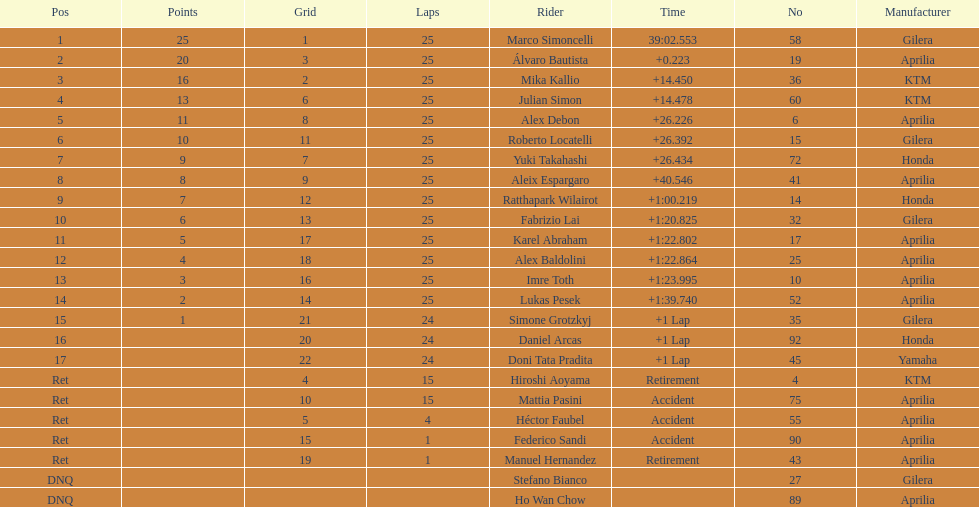How many laps did marco perform? 25. How many laps did hiroshi perform? 15. Which of these numbers are higher? 25. Who swam this number of laps? Marco Simoncelli. 